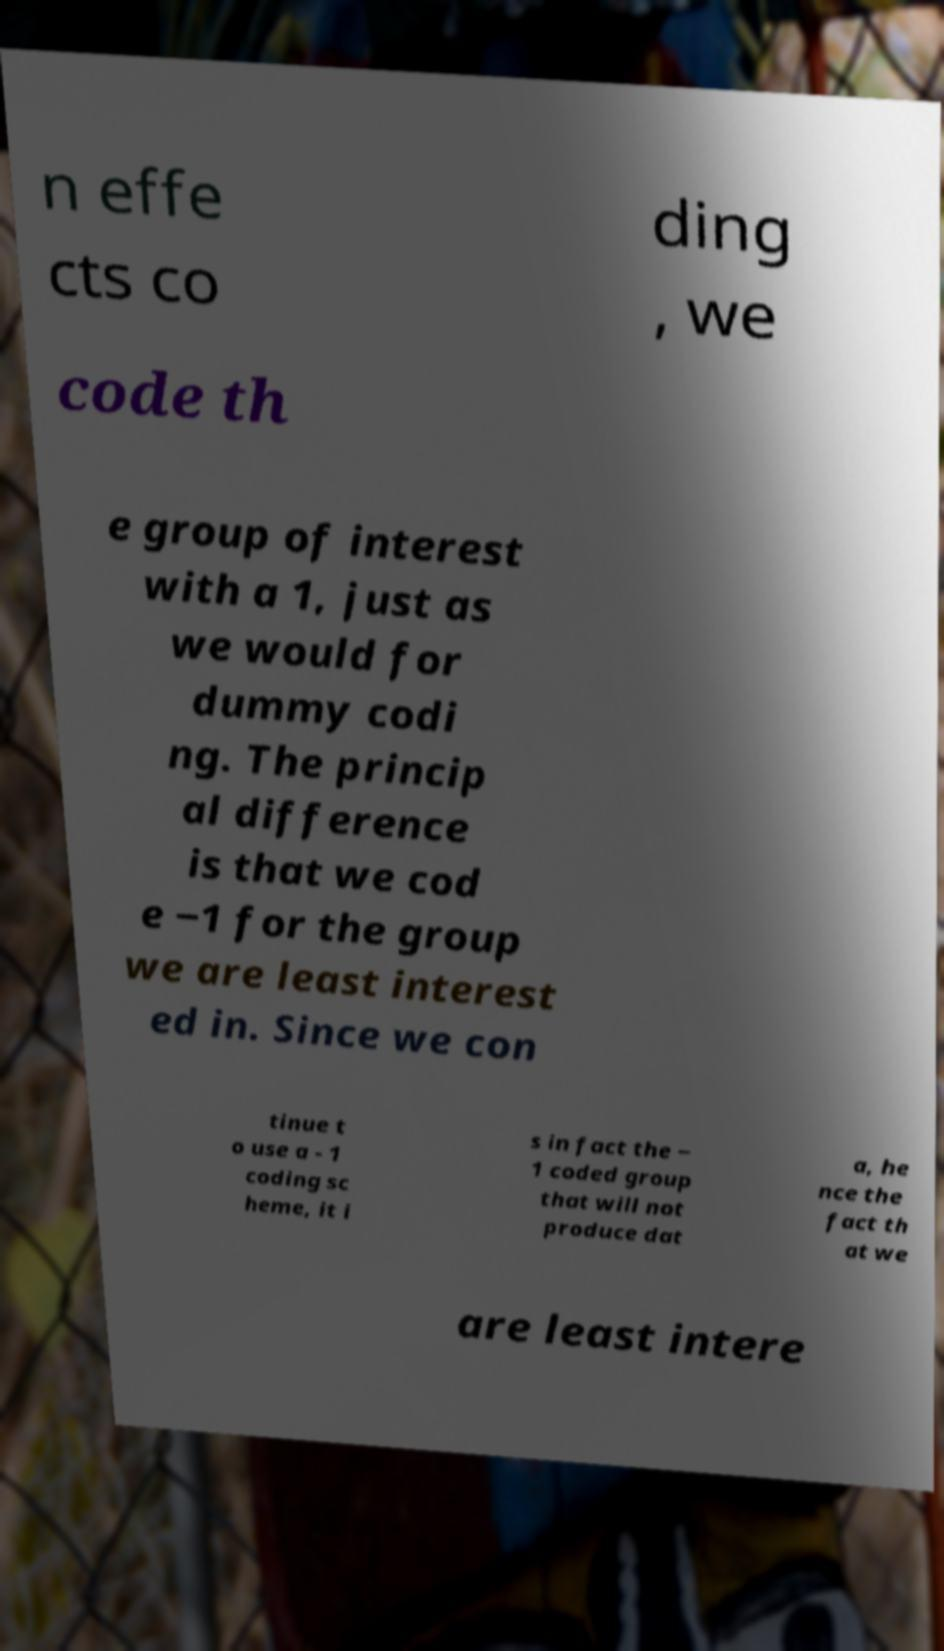Can you read and provide the text displayed in the image?This photo seems to have some interesting text. Can you extract and type it out for me? n effe cts co ding , we code th e group of interest with a 1, just as we would for dummy codi ng. The princip al difference is that we cod e −1 for the group we are least interest ed in. Since we con tinue t o use a - 1 coding sc heme, it i s in fact the − 1 coded group that will not produce dat a, he nce the fact th at we are least intere 